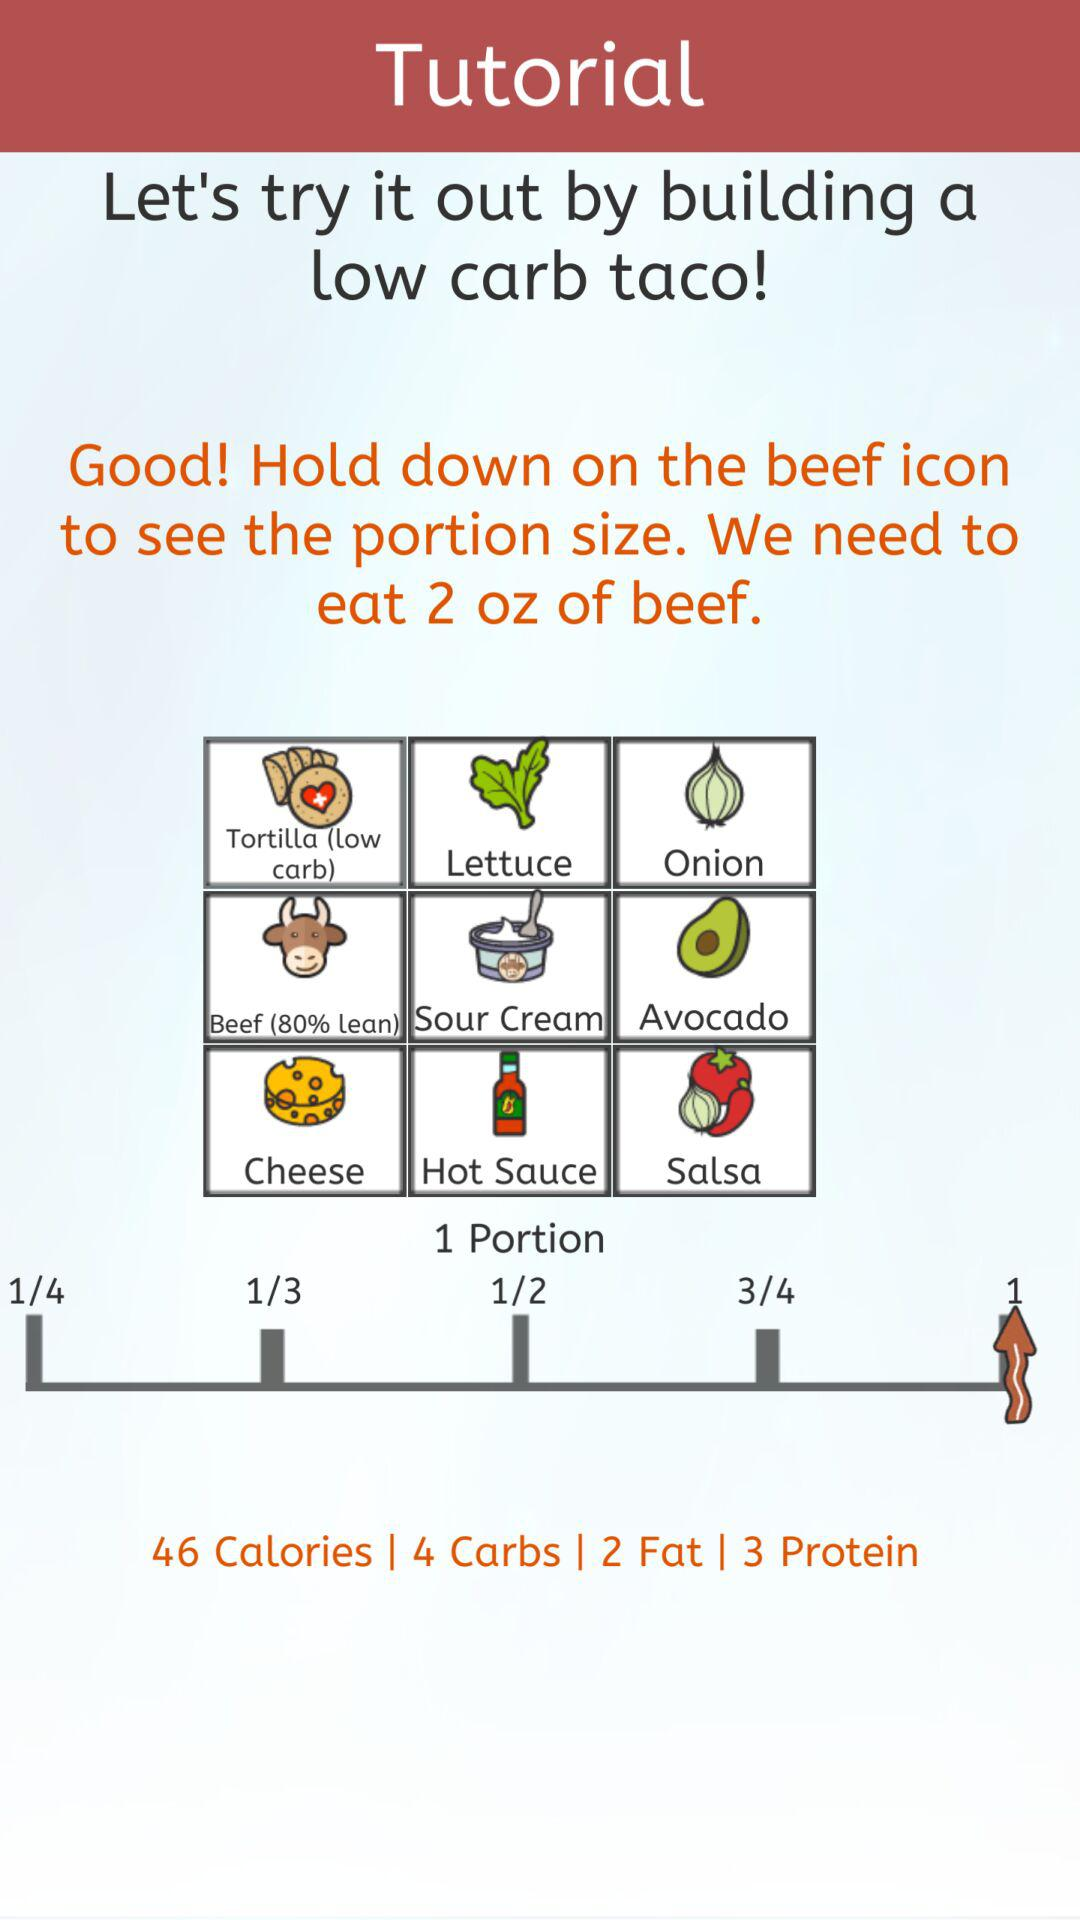How many different portion sizes are there?
Answer the question using a single word or phrase. 5 